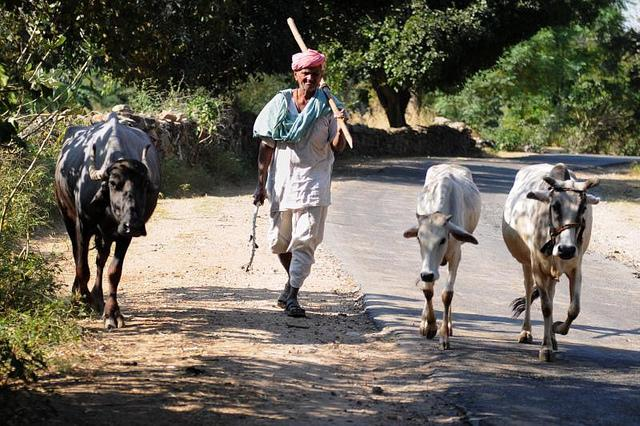What color is the turban worn by the man herding the cows? red 